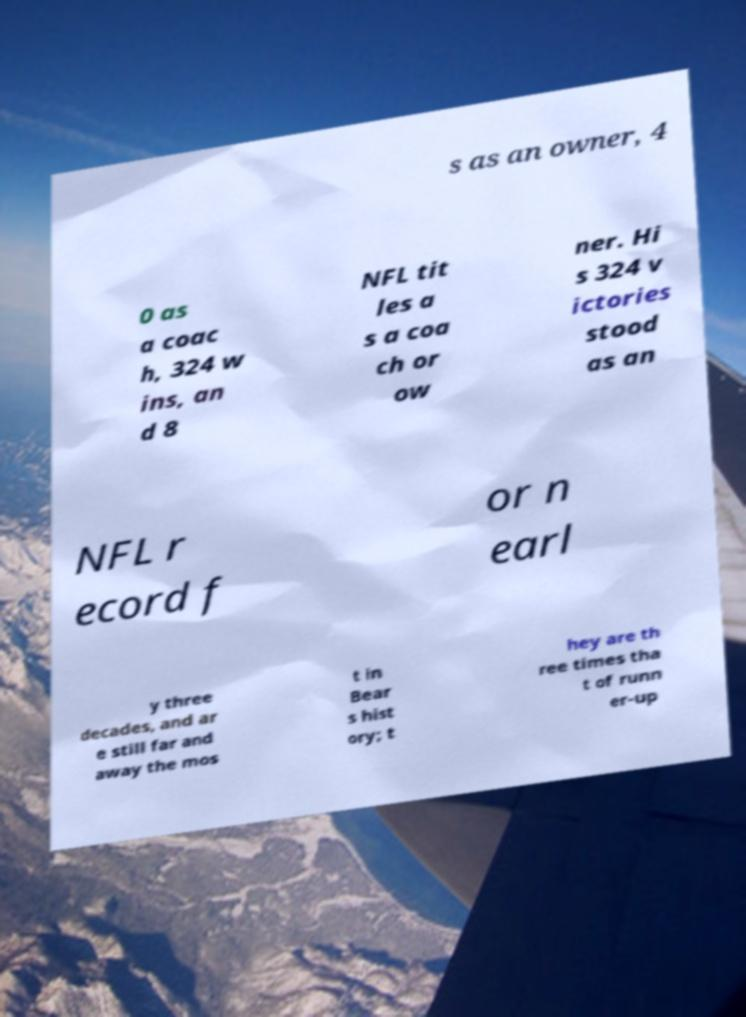There's text embedded in this image that I need extracted. Can you transcribe it verbatim? s as an owner, 4 0 as a coac h, 324 w ins, an d 8 NFL tit les a s a coa ch or ow ner. Hi s 324 v ictories stood as an NFL r ecord f or n earl y three decades, and ar e still far and away the mos t in Bear s hist ory; t hey are th ree times tha t of runn er-up 